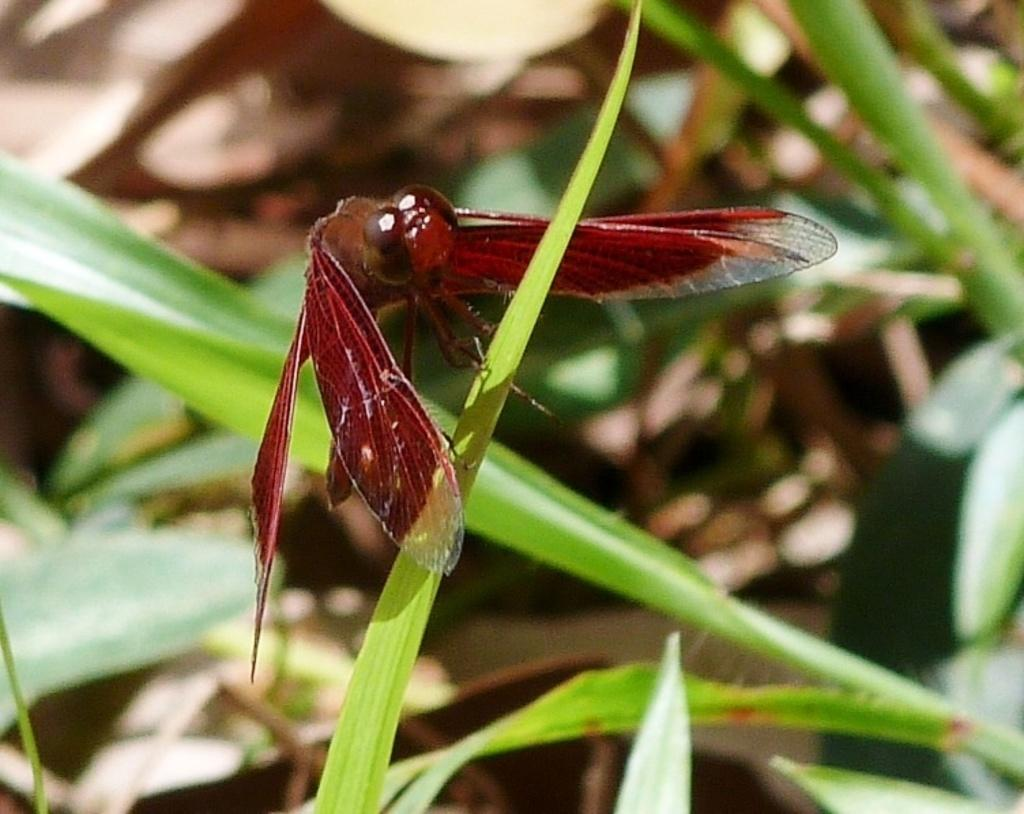What type of creature is in the image? There is an insect in the image. Where is the insect located? The insect is on the grass. Can you describe the background of the image? The background of the image is blurred. What type of pie is the insect eating in the image? There is no pie present in the image; it features an insect on the grass. How many dogs are visible in the image? There are no dogs present in the image. 